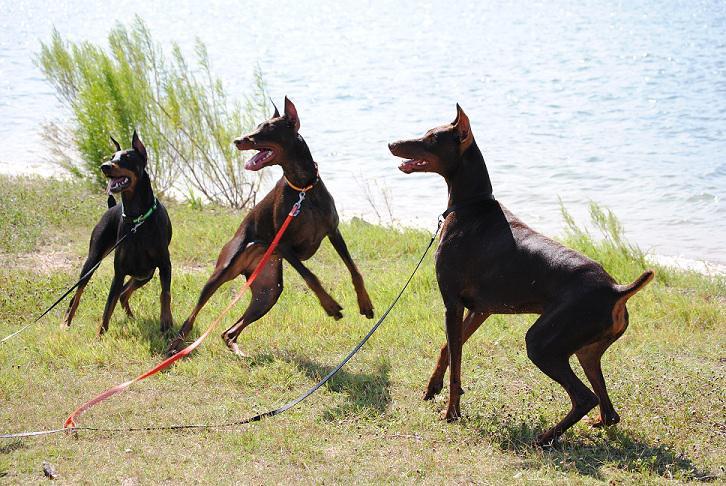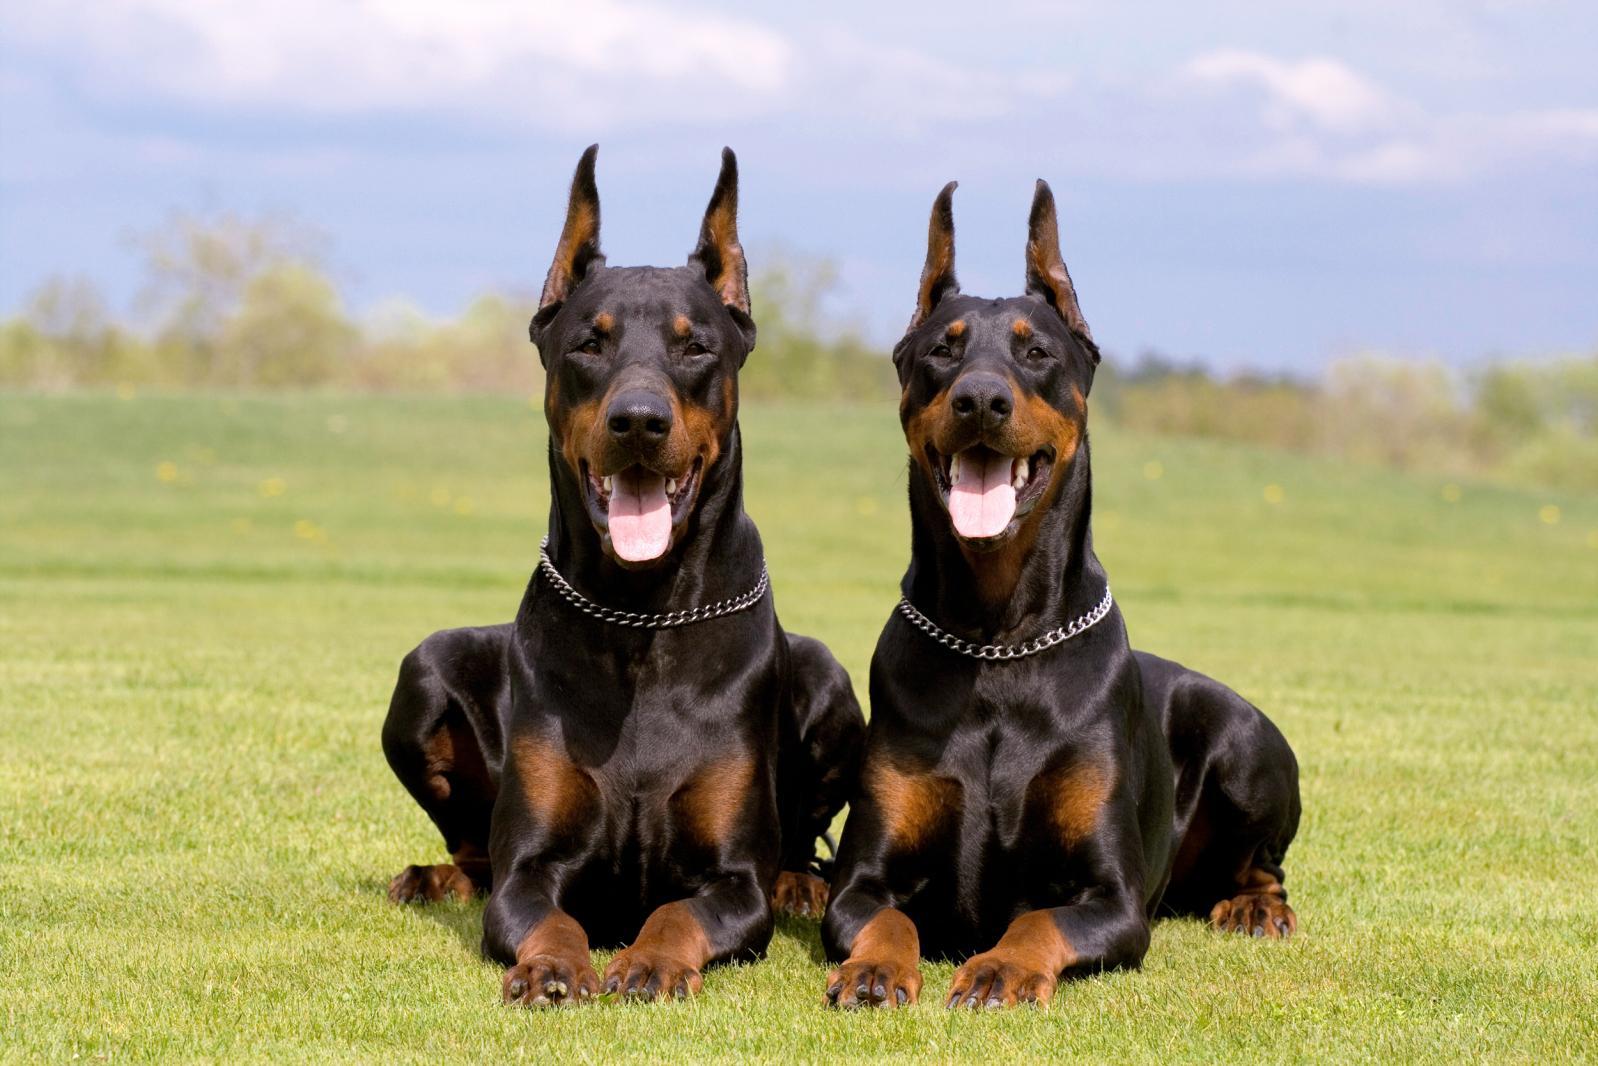The first image is the image on the left, the second image is the image on the right. Given the left and right images, does the statement "There are two or more dogs standing in the left image and laying down in the right." hold true? Answer yes or no. Yes. The first image is the image on the left, the second image is the image on the right. Evaluate the accuracy of this statement regarding the images: "The left image contains at least two dogs.". Is it true? Answer yes or no. Yes. 